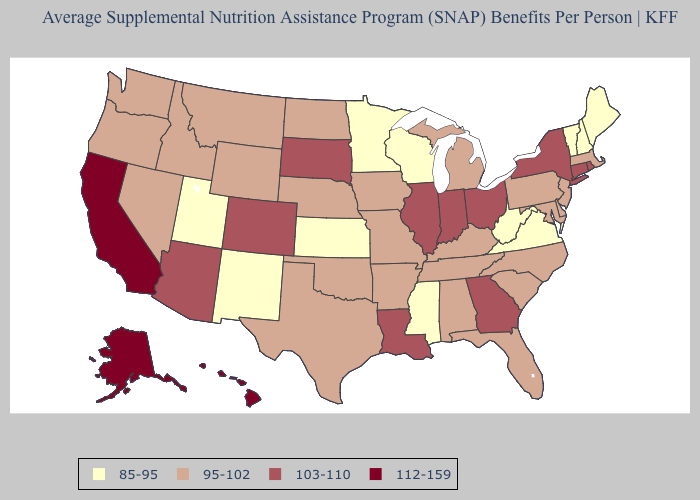Among the states that border Massachusetts , does Connecticut have the lowest value?
Answer briefly. No. Among the states that border Vermont , does Massachusetts have the lowest value?
Short answer required. No. Name the states that have a value in the range 112-159?
Short answer required. Alaska, California, Hawaii. Does Wisconsin have the lowest value in the MidWest?
Quick response, please. Yes. Among the states that border Nebraska , does South Dakota have the highest value?
Write a very short answer. Yes. What is the highest value in the USA?
Give a very brief answer. 112-159. Is the legend a continuous bar?
Write a very short answer. No. Name the states that have a value in the range 103-110?
Keep it brief. Arizona, Colorado, Connecticut, Georgia, Illinois, Indiana, Louisiana, New York, Ohio, Rhode Island, South Dakota. Name the states that have a value in the range 112-159?
Give a very brief answer. Alaska, California, Hawaii. What is the lowest value in the Northeast?
Write a very short answer. 85-95. Name the states that have a value in the range 95-102?
Quick response, please. Alabama, Arkansas, Delaware, Florida, Idaho, Iowa, Kentucky, Maryland, Massachusetts, Michigan, Missouri, Montana, Nebraska, Nevada, New Jersey, North Carolina, North Dakota, Oklahoma, Oregon, Pennsylvania, South Carolina, Tennessee, Texas, Washington, Wyoming. How many symbols are there in the legend?
Answer briefly. 4. Does Kansas have the same value as New Hampshire?
Answer briefly. Yes. Name the states that have a value in the range 103-110?
Short answer required. Arizona, Colorado, Connecticut, Georgia, Illinois, Indiana, Louisiana, New York, Ohio, Rhode Island, South Dakota. Does Nevada have the same value as California?
Give a very brief answer. No. 